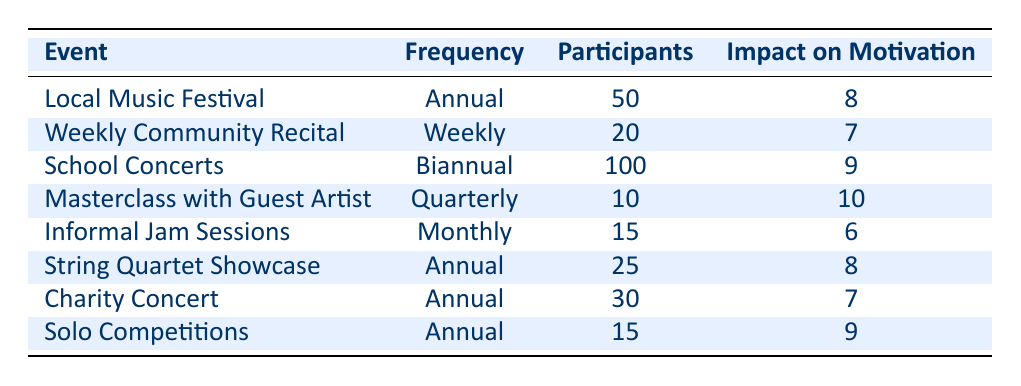What is the frequency of the "Charity Concert" event? The table lists the performance events along with their frequencies. By locating the "Charity Concert" row in the Event column, we can see that its frequency is indicated in the Frequency column.
Answer: Annual How many participants are involved in the "Masterclass with Guest Artist"? In the table, the number of participants for each event is given in the Participants column. For the "Masterclass with Guest Artist", by referencing its row, we find that there are 10 participants.
Answer: 10 What is the average impact on motivation of events held annually? To find the average impact on motivation for annual events, we need to identify all annual events and their impact scores, which are: 8 (Local Music Festival), 8 (String Quartet Showcase), 7 (Charity Concert), and 9 (Solo Competitions). Then, we sum these impact values: 8 + 8 + 7 + 9 = 32. Since there are 4 annual events, the average impact is 32 / 4 = 8.
Answer: 8 Is the impact on motivation for "Informal Jam Sessions" higher than that of "Weekly Community Recital"? The impact on motivation for both events can be found in the Impact on Motivation column. "Informal Jam Sessions" has a score of 6, while "Weekly Community Recital" has a score of 7. Comparing these two scores shows that 6 is not higher than 7.
Answer: No Which event has the highest impact on motivation and what is that value? The table contains an Impact on Motivation column where we need to find the maximum value among all events. Examining the data, the highest score is 10 for the "Masterclass with Guest Artist". Thus, the highest impact on motivation is 10.
Answer: 10 